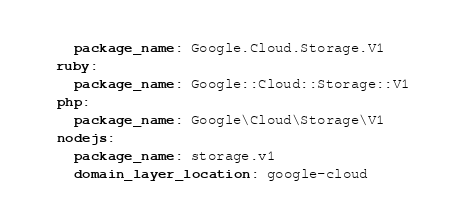<code> <loc_0><loc_0><loc_500><loc_500><_YAML_>    package_name: Google.Cloud.Storage.V1
  ruby:
    package_name: Google::Cloud::Storage::V1
  php:
    package_name: Google\Cloud\Storage\V1
  nodejs:
    package_name: storage.v1
    domain_layer_location: google-cloud
</code> 